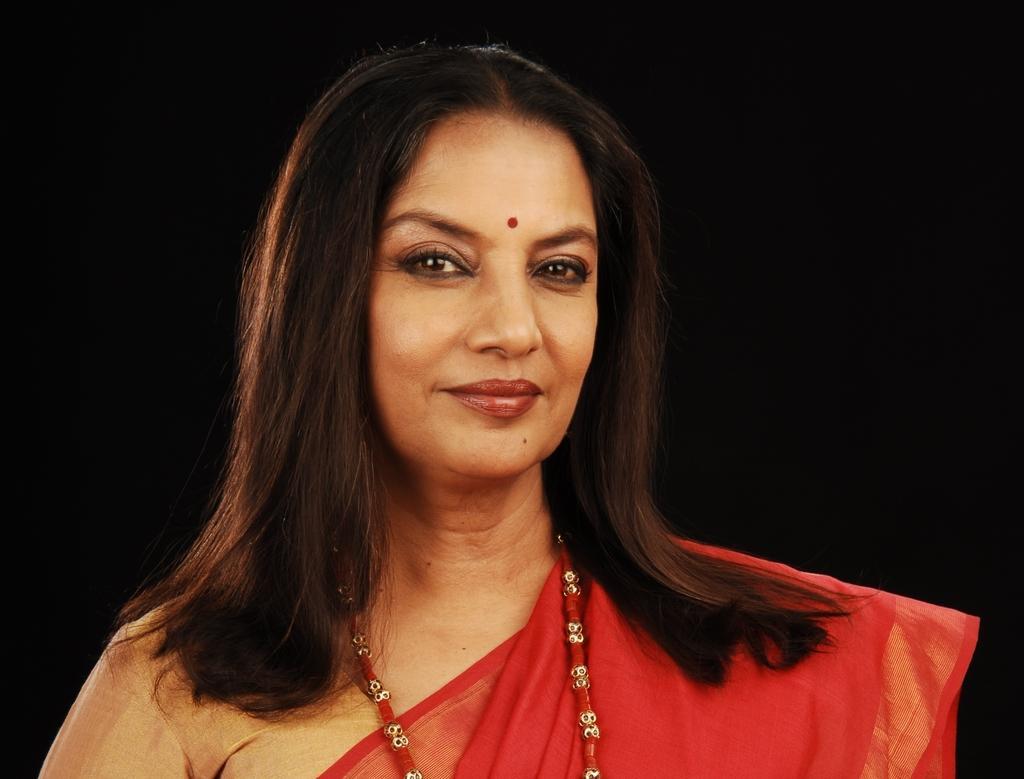In one or two sentences, can you explain what this image depicts? In this image there is a picture of shabana azmi. 